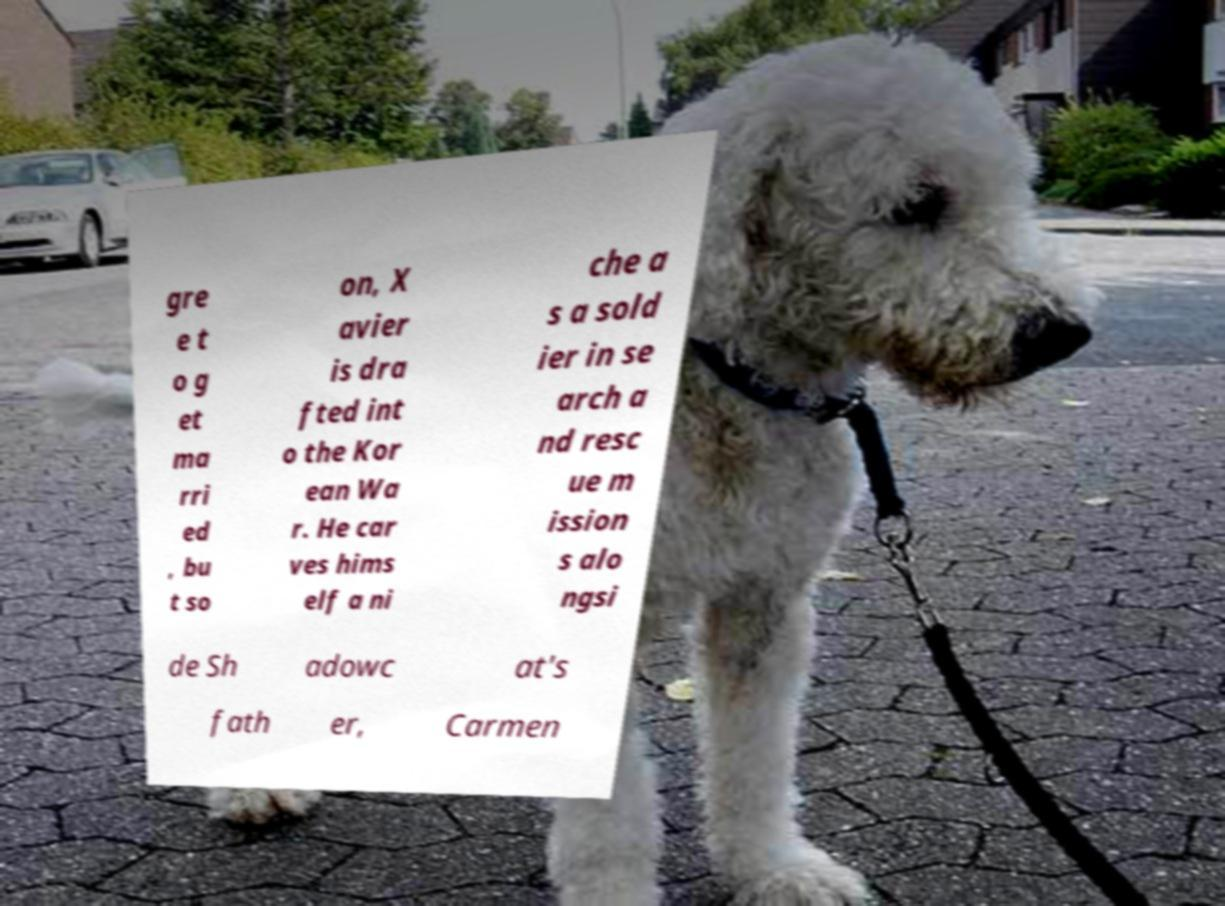I need the written content from this picture converted into text. Can you do that? gre e t o g et ma rri ed , bu t so on, X avier is dra fted int o the Kor ean Wa r. He car ves hims elf a ni che a s a sold ier in se arch a nd resc ue m ission s alo ngsi de Sh adowc at's fath er, Carmen 